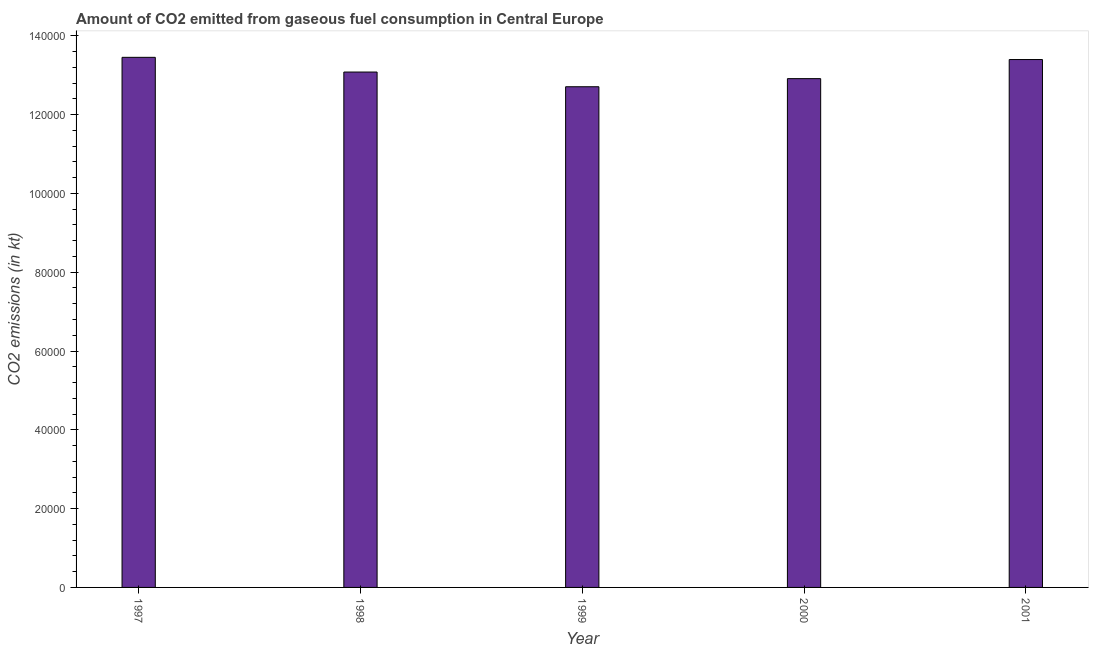Does the graph contain any zero values?
Your answer should be very brief. No. What is the title of the graph?
Your answer should be very brief. Amount of CO2 emitted from gaseous fuel consumption in Central Europe. What is the label or title of the X-axis?
Keep it short and to the point. Year. What is the label or title of the Y-axis?
Ensure brevity in your answer.  CO2 emissions (in kt). What is the co2 emissions from gaseous fuel consumption in 1997?
Your answer should be compact. 1.35e+05. Across all years, what is the maximum co2 emissions from gaseous fuel consumption?
Your answer should be very brief. 1.35e+05. Across all years, what is the minimum co2 emissions from gaseous fuel consumption?
Give a very brief answer. 1.27e+05. What is the sum of the co2 emissions from gaseous fuel consumption?
Provide a short and direct response. 6.56e+05. What is the difference between the co2 emissions from gaseous fuel consumption in 1998 and 2000?
Your response must be concise. 1675.82. What is the average co2 emissions from gaseous fuel consumption per year?
Provide a succinct answer. 1.31e+05. What is the median co2 emissions from gaseous fuel consumption?
Offer a very short reply. 1.31e+05. What is the ratio of the co2 emissions from gaseous fuel consumption in 1999 to that in 2001?
Your response must be concise. 0.95. What is the difference between the highest and the second highest co2 emissions from gaseous fuel consumption?
Ensure brevity in your answer.  561.05. Is the sum of the co2 emissions from gaseous fuel consumption in 1997 and 1998 greater than the maximum co2 emissions from gaseous fuel consumption across all years?
Offer a terse response. Yes. What is the difference between the highest and the lowest co2 emissions from gaseous fuel consumption?
Your answer should be very brief. 7466.01. In how many years, is the co2 emissions from gaseous fuel consumption greater than the average co2 emissions from gaseous fuel consumption taken over all years?
Provide a short and direct response. 2. Are all the bars in the graph horizontal?
Your response must be concise. No. How many years are there in the graph?
Your answer should be very brief. 5. What is the CO2 emissions (in kt) in 1997?
Provide a short and direct response. 1.35e+05. What is the CO2 emissions (in kt) of 1998?
Give a very brief answer. 1.31e+05. What is the CO2 emissions (in kt) in 1999?
Provide a short and direct response. 1.27e+05. What is the CO2 emissions (in kt) in 2000?
Give a very brief answer. 1.29e+05. What is the CO2 emissions (in kt) in 2001?
Give a very brief answer. 1.34e+05. What is the difference between the CO2 emissions (in kt) in 1997 and 1998?
Provide a succinct answer. 3733.01. What is the difference between the CO2 emissions (in kt) in 1997 and 1999?
Give a very brief answer. 7466.01. What is the difference between the CO2 emissions (in kt) in 1997 and 2000?
Keep it short and to the point. 5408.82. What is the difference between the CO2 emissions (in kt) in 1997 and 2001?
Make the answer very short. 561.05. What is the difference between the CO2 emissions (in kt) in 1998 and 1999?
Your answer should be compact. 3733.01. What is the difference between the CO2 emissions (in kt) in 1998 and 2000?
Ensure brevity in your answer.  1675.82. What is the difference between the CO2 emissions (in kt) in 1998 and 2001?
Your answer should be compact. -3171.95. What is the difference between the CO2 emissions (in kt) in 1999 and 2000?
Provide a short and direct response. -2057.19. What is the difference between the CO2 emissions (in kt) in 1999 and 2001?
Give a very brief answer. -6904.96. What is the difference between the CO2 emissions (in kt) in 2000 and 2001?
Your response must be concise. -4847.77. What is the ratio of the CO2 emissions (in kt) in 1997 to that in 1999?
Your answer should be compact. 1.06. What is the ratio of the CO2 emissions (in kt) in 1997 to that in 2000?
Provide a short and direct response. 1.04. What is the ratio of the CO2 emissions (in kt) in 1998 to that in 1999?
Keep it short and to the point. 1.03. What is the ratio of the CO2 emissions (in kt) in 1999 to that in 2000?
Your response must be concise. 0.98. What is the ratio of the CO2 emissions (in kt) in 1999 to that in 2001?
Make the answer very short. 0.95. What is the ratio of the CO2 emissions (in kt) in 2000 to that in 2001?
Provide a succinct answer. 0.96. 